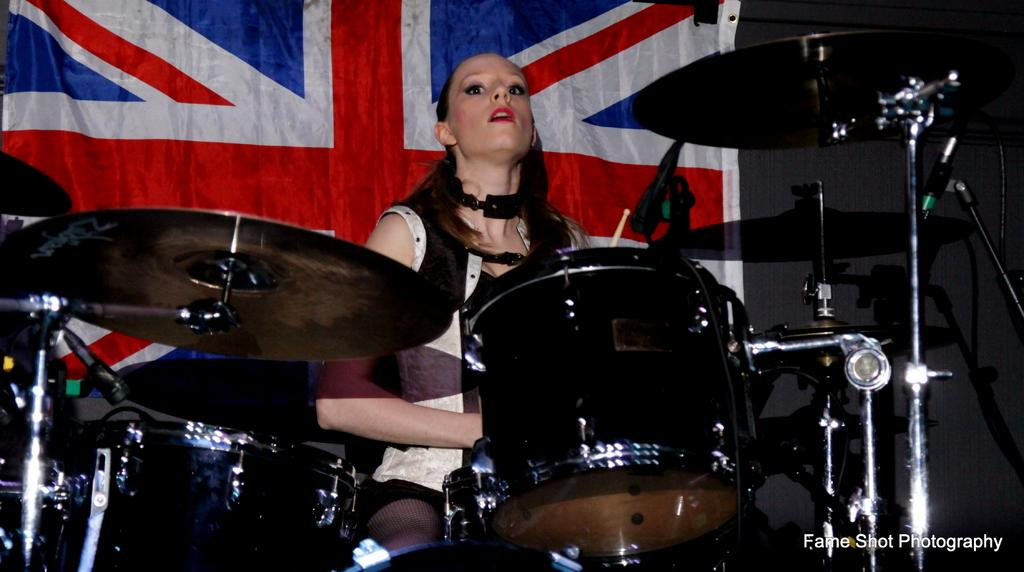What is the woman in the image doing? The woman is playing drums in the image. What other percussion instrument is present in the image? Cymbals are present in the image. What type of musical instrument is the main focus of the image? Drums are visible in the image. What can be seen in the background of the image? There is a flag in the background of the image. Where is the text located in the image? The text is at the right bottom of the image. What type of fruit can be seen growing on the slope in the image? There is no fruit or slope present in the image; it features a woman playing drums with cymbals and a flag in the background. 